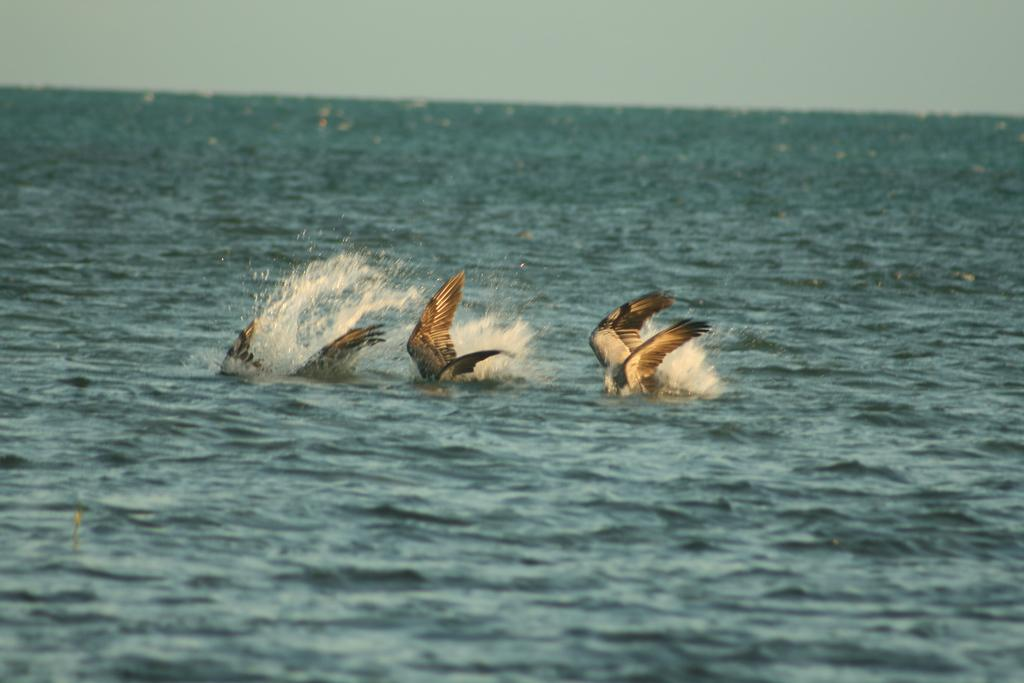What is the main setting of the image? The main setting of the image is a sea. What can be seen in the sea in the image? There is an object in the sea, which appears to be three birds with wings in the water. What is visible at the top of the image? The sky is visible at the top of the image. What type of tool is the carpenter using in the image? There is no carpenter or tool present in the image. How many numbers can be seen on the calculator in the image? There is no calculator present in the image. 